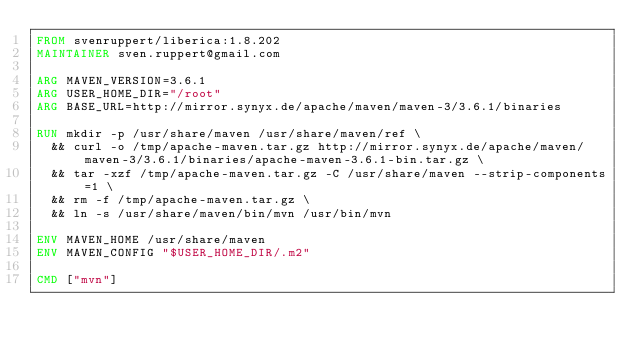Convert code to text. <code><loc_0><loc_0><loc_500><loc_500><_Dockerfile_>FROM svenruppert/liberica:1.8.202
MAINTAINER sven.ruppert@gmail.com

ARG MAVEN_VERSION=3.6.1
ARG USER_HOME_DIR="/root"
ARG BASE_URL=http://mirror.synyx.de/apache/maven/maven-3/3.6.1/binaries

RUN mkdir -p /usr/share/maven /usr/share/maven/ref \
  && curl -o /tmp/apache-maven.tar.gz http://mirror.synyx.de/apache/maven/maven-3/3.6.1/binaries/apache-maven-3.6.1-bin.tar.gz \
  && tar -xzf /tmp/apache-maven.tar.gz -C /usr/share/maven --strip-components=1 \
  && rm -f /tmp/apache-maven.tar.gz \
  && ln -s /usr/share/maven/bin/mvn /usr/bin/mvn

ENV MAVEN_HOME /usr/share/maven
ENV MAVEN_CONFIG "$USER_HOME_DIR/.m2"

CMD ["mvn"]</code> 